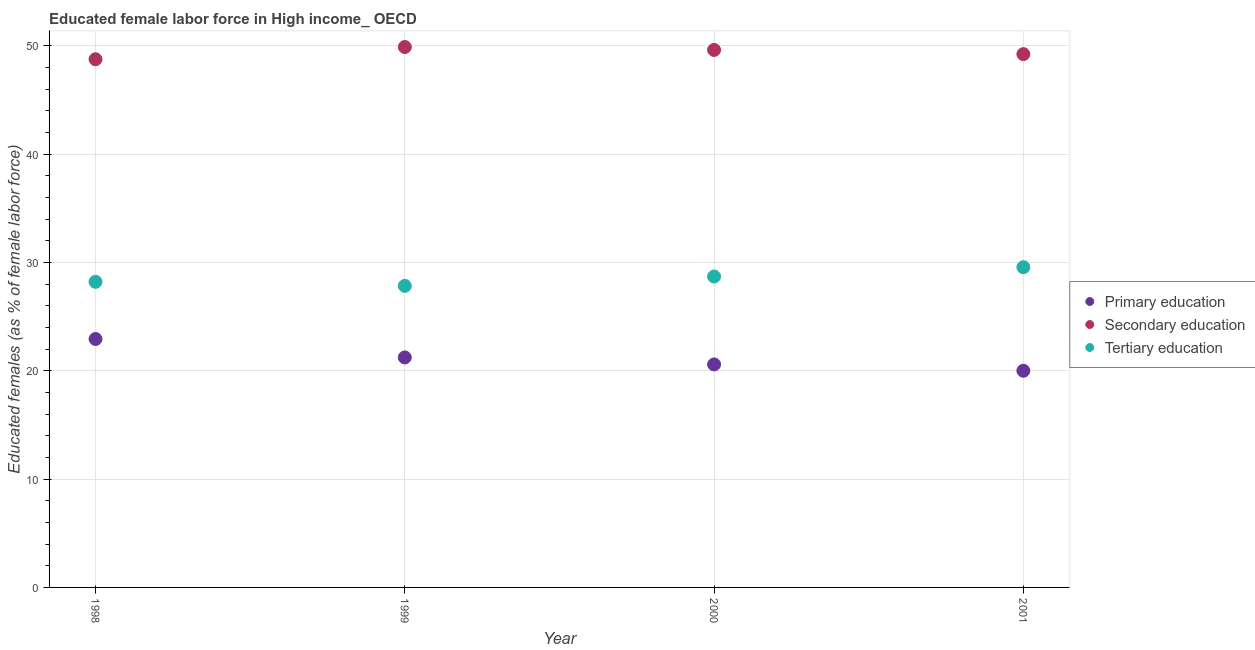How many different coloured dotlines are there?
Ensure brevity in your answer.  3. What is the percentage of female labor force who received secondary education in 1998?
Provide a short and direct response. 48.76. Across all years, what is the maximum percentage of female labor force who received secondary education?
Your answer should be compact. 49.89. Across all years, what is the minimum percentage of female labor force who received tertiary education?
Offer a very short reply. 27.84. What is the total percentage of female labor force who received tertiary education in the graph?
Provide a short and direct response. 114.32. What is the difference between the percentage of female labor force who received primary education in 1998 and that in 2000?
Offer a very short reply. 2.35. What is the difference between the percentage of female labor force who received primary education in 1999 and the percentage of female labor force who received secondary education in 2000?
Provide a short and direct response. -28.39. What is the average percentage of female labor force who received secondary education per year?
Offer a terse response. 49.38. In the year 1998, what is the difference between the percentage of female labor force who received primary education and percentage of female labor force who received secondary education?
Give a very brief answer. -25.83. In how many years, is the percentage of female labor force who received tertiary education greater than 36 %?
Provide a short and direct response. 0. What is the ratio of the percentage of female labor force who received tertiary education in 1999 to that in 2000?
Keep it short and to the point. 0.97. What is the difference between the highest and the second highest percentage of female labor force who received primary education?
Make the answer very short. 1.7. What is the difference between the highest and the lowest percentage of female labor force who received primary education?
Offer a terse response. 2.93. Is the sum of the percentage of female labor force who received tertiary education in 1998 and 1999 greater than the maximum percentage of female labor force who received secondary education across all years?
Make the answer very short. Yes. Is the percentage of female labor force who received primary education strictly greater than the percentage of female labor force who received secondary education over the years?
Ensure brevity in your answer.  No. What is the difference between two consecutive major ticks on the Y-axis?
Keep it short and to the point. 10. Does the graph contain any zero values?
Keep it short and to the point. No. What is the title of the graph?
Provide a succinct answer. Educated female labor force in High income_ OECD. What is the label or title of the X-axis?
Offer a terse response. Year. What is the label or title of the Y-axis?
Offer a very short reply. Educated females (as % of female labor force). What is the Educated females (as % of female labor force) of Primary education in 1998?
Give a very brief answer. 22.94. What is the Educated females (as % of female labor force) of Secondary education in 1998?
Your response must be concise. 48.76. What is the Educated females (as % of female labor force) of Tertiary education in 1998?
Give a very brief answer. 28.22. What is the Educated females (as % of female labor force) in Primary education in 1999?
Make the answer very short. 21.23. What is the Educated females (as % of female labor force) in Secondary education in 1999?
Provide a succinct answer. 49.89. What is the Educated females (as % of female labor force) in Tertiary education in 1999?
Ensure brevity in your answer.  27.84. What is the Educated females (as % of female labor force) in Primary education in 2000?
Provide a succinct answer. 20.59. What is the Educated females (as % of female labor force) in Secondary education in 2000?
Offer a terse response. 49.62. What is the Educated females (as % of female labor force) in Tertiary education in 2000?
Keep it short and to the point. 28.7. What is the Educated females (as % of female labor force) of Primary education in 2001?
Give a very brief answer. 20. What is the Educated females (as % of female labor force) of Secondary education in 2001?
Provide a succinct answer. 49.23. What is the Educated females (as % of female labor force) in Tertiary education in 2001?
Your response must be concise. 29.56. Across all years, what is the maximum Educated females (as % of female labor force) of Primary education?
Make the answer very short. 22.94. Across all years, what is the maximum Educated females (as % of female labor force) of Secondary education?
Offer a very short reply. 49.89. Across all years, what is the maximum Educated females (as % of female labor force) in Tertiary education?
Make the answer very short. 29.56. Across all years, what is the minimum Educated females (as % of female labor force) in Primary education?
Offer a very short reply. 20. Across all years, what is the minimum Educated females (as % of female labor force) in Secondary education?
Provide a short and direct response. 48.76. Across all years, what is the minimum Educated females (as % of female labor force) of Tertiary education?
Make the answer very short. 27.84. What is the total Educated females (as % of female labor force) of Primary education in the graph?
Ensure brevity in your answer.  84.76. What is the total Educated females (as % of female labor force) in Secondary education in the graph?
Provide a short and direct response. 197.51. What is the total Educated females (as % of female labor force) in Tertiary education in the graph?
Offer a very short reply. 114.32. What is the difference between the Educated females (as % of female labor force) in Primary education in 1998 and that in 1999?
Keep it short and to the point. 1.7. What is the difference between the Educated females (as % of female labor force) of Secondary education in 1998 and that in 1999?
Keep it short and to the point. -1.13. What is the difference between the Educated females (as % of female labor force) in Tertiary education in 1998 and that in 1999?
Your response must be concise. 0.38. What is the difference between the Educated females (as % of female labor force) of Primary education in 1998 and that in 2000?
Provide a succinct answer. 2.35. What is the difference between the Educated females (as % of female labor force) of Secondary education in 1998 and that in 2000?
Give a very brief answer. -0.86. What is the difference between the Educated females (as % of female labor force) in Tertiary education in 1998 and that in 2000?
Your answer should be compact. -0.49. What is the difference between the Educated females (as % of female labor force) in Primary education in 1998 and that in 2001?
Your answer should be compact. 2.93. What is the difference between the Educated females (as % of female labor force) of Secondary education in 1998 and that in 2001?
Your answer should be very brief. -0.47. What is the difference between the Educated females (as % of female labor force) in Tertiary education in 1998 and that in 2001?
Offer a terse response. -1.35. What is the difference between the Educated females (as % of female labor force) of Primary education in 1999 and that in 2000?
Your answer should be compact. 0.65. What is the difference between the Educated females (as % of female labor force) of Secondary education in 1999 and that in 2000?
Keep it short and to the point. 0.27. What is the difference between the Educated females (as % of female labor force) of Tertiary education in 1999 and that in 2000?
Your answer should be very brief. -0.86. What is the difference between the Educated females (as % of female labor force) in Primary education in 1999 and that in 2001?
Your answer should be very brief. 1.23. What is the difference between the Educated females (as % of female labor force) of Secondary education in 1999 and that in 2001?
Make the answer very short. 0.66. What is the difference between the Educated females (as % of female labor force) of Tertiary education in 1999 and that in 2001?
Offer a terse response. -1.72. What is the difference between the Educated females (as % of female labor force) in Primary education in 2000 and that in 2001?
Provide a short and direct response. 0.59. What is the difference between the Educated females (as % of female labor force) in Secondary education in 2000 and that in 2001?
Provide a short and direct response. 0.39. What is the difference between the Educated females (as % of female labor force) in Tertiary education in 2000 and that in 2001?
Your response must be concise. -0.86. What is the difference between the Educated females (as % of female labor force) in Primary education in 1998 and the Educated females (as % of female labor force) in Secondary education in 1999?
Keep it short and to the point. -26.96. What is the difference between the Educated females (as % of female labor force) in Primary education in 1998 and the Educated females (as % of female labor force) in Tertiary education in 1999?
Provide a succinct answer. -4.9. What is the difference between the Educated females (as % of female labor force) of Secondary education in 1998 and the Educated females (as % of female labor force) of Tertiary education in 1999?
Keep it short and to the point. 20.92. What is the difference between the Educated females (as % of female labor force) in Primary education in 1998 and the Educated females (as % of female labor force) in Secondary education in 2000?
Offer a terse response. -26.69. What is the difference between the Educated females (as % of female labor force) in Primary education in 1998 and the Educated females (as % of female labor force) in Tertiary education in 2000?
Offer a very short reply. -5.77. What is the difference between the Educated females (as % of female labor force) of Secondary education in 1998 and the Educated females (as % of female labor force) of Tertiary education in 2000?
Your response must be concise. 20.06. What is the difference between the Educated females (as % of female labor force) in Primary education in 1998 and the Educated females (as % of female labor force) in Secondary education in 2001?
Provide a short and direct response. -26.3. What is the difference between the Educated females (as % of female labor force) of Primary education in 1998 and the Educated females (as % of female labor force) of Tertiary education in 2001?
Offer a very short reply. -6.63. What is the difference between the Educated females (as % of female labor force) in Secondary education in 1998 and the Educated females (as % of female labor force) in Tertiary education in 2001?
Offer a very short reply. 19.2. What is the difference between the Educated females (as % of female labor force) of Primary education in 1999 and the Educated females (as % of female labor force) of Secondary education in 2000?
Provide a succinct answer. -28.39. What is the difference between the Educated females (as % of female labor force) of Primary education in 1999 and the Educated females (as % of female labor force) of Tertiary education in 2000?
Give a very brief answer. -7.47. What is the difference between the Educated females (as % of female labor force) in Secondary education in 1999 and the Educated females (as % of female labor force) in Tertiary education in 2000?
Ensure brevity in your answer.  21.19. What is the difference between the Educated females (as % of female labor force) in Primary education in 1999 and the Educated females (as % of female labor force) in Secondary education in 2001?
Give a very brief answer. -28. What is the difference between the Educated females (as % of female labor force) in Primary education in 1999 and the Educated females (as % of female labor force) in Tertiary education in 2001?
Ensure brevity in your answer.  -8.33. What is the difference between the Educated females (as % of female labor force) of Secondary education in 1999 and the Educated females (as % of female labor force) of Tertiary education in 2001?
Give a very brief answer. 20.33. What is the difference between the Educated females (as % of female labor force) in Primary education in 2000 and the Educated females (as % of female labor force) in Secondary education in 2001?
Your answer should be compact. -28.65. What is the difference between the Educated females (as % of female labor force) of Primary education in 2000 and the Educated females (as % of female labor force) of Tertiary education in 2001?
Your response must be concise. -8.97. What is the difference between the Educated females (as % of female labor force) in Secondary education in 2000 and the Educated females (as % of female labor force) in Tertiary education in 2001?
Give a very brief answer. 20.06. What is the average Educated females (as % of female labor force) in Primary education per year?
Provide a short and direct response. 21.19. What is the average Educated females (as % of female labor force) of Secondary education per year?
Make the answer very short. 49.38. What is the average Educated females (as % of female labor force) in Tertiary education per year?
Offer a terse response. 28.58. In the year 1998, what is the difference between the Educated females (as % of female labor force) in Primary education and Educated females (as % of female labor force) in Secondary education?
Your answer should be very brief. -25.83. In the year 1998, what is the difference between the Educated females (as % of female labor force) in Primary education and Educated females (as % of female labor force) in Tertiary education?
Your answer should be very brief. -5.28. In the year 1998, what is the difference between the Educated females (as % of female labor force) in Secondary education and Educated females (as % of female labor force) in Tertiary education?
Provide a succinct answer. 20.55. In the year 1999, what is the difference between the Educated females (as % of female labor force) of Primary education and Educated females (as % of female labor force) of Secondary education?
Provide a succinct answer. -28.66. In the year 1999, what is the difference between the Educated females (as % of female labor force) of Primary education and Educated females (as % of female labor force) of Tertiary education?
Keep it short and to the point. -6.61. In the year 1999, what is the difference between the Educated females (as % of female labor force) of Secondary education and Educated females (as % of female labor force) of Tertiary education?
Your answer should be very brief. 22.05. In the year 2000, what is the difference between the Educated females (as % of female labor force) in Primary education and Educated females (as % of female labor force) in Secondary education?
Your answer should be compact. -29.03. In the year 2000, what is the difference between the Educated females (as % of female labor force) of Primary education and Educated females (as % of female labor force) of Tertiary education?
Offer a very short reply. -8.12. In the year 2000, what is the difference between the Educated females (as % of female labor force) of Secondary education and Educated females (as % of female labor force) of Tertiary education?
Offer a very short reply. 20.92. In the year 2001, what is the difference between the Educated females (as % of female labor force) in Primary education and Educated females (as % of female labor force) in Secondary education?
Provide a succinct answer. -29.23. In the year 2001, what is the difference between the Educated females (as % of female labor force) of Primary education and Educated females (as % of female labor force) of Tertiary education?
Make the answer very short. -9.56. In the year 2001, what is the difference between the Educated females (as % of female labor force) in Secondary education and Educated females (as % of female labor force) in Tertiary education?
Make the answer very short. 19.67. What is the ratio of the Educated females (as % of female labor force) in Primary education in 1998 to that in 1999?
Offer a terse response. 1.08. What is the ratio of the Educated females (as % of female labor force) of Secondary education in 1998 to that in 1999?
Give a very brief answer. 0.98. What is the ratio of the Educated females (as % of female labor force) in Tertiary education in 1998 to that in 1999?
Give a very brief answer. 1.01. What is the ratio of the Educated females (as % of female labor force) in Primary education in 1998 to that in 2000?
Give a very brief answer. 1.11. What is the ratio of the Educated females (as % of female labor force) in Secondary education in 1998 to that in 2000?
Offer a terse response. 0.98. What is the ratio of the Educated females (as % of female labor force) in Tertiary education in 1998 to that in 2000?
Offer a terse response. 0.98. What is the ratio of the Educated females (as % of female labor force) in Primary education in 1998 to that in 2001?
Offer a very short reply. 1.15. What is the ratio of the Educated females (as % of female labor force) in Secondary education in 1998 to that in 2001?
Provide a succinct answer. 0.99. What is the ratio of the Educated females (as % of female labor force) of Tertiary education in 1998 to that in 2001?
Make the answer very short. 0.95. What is the ratio of the Educated females (as % of female labor force) of Primary education in 1999 to that in 2000?
Provide a short and direct response. 1.03. What is the ratio of the Educated females (as % of female labor force) of Secondary education in 1999 to that in 2000?
Ensure brevity in your answer.  1.01. What is the ratio of the Educated females (as % of female labor force) of Tertiary education in 1999 to that in 2000?
Ensure brevity in your answer.  0.97. What is the ratio of the Educated females (as % of female labor force) of Primary education in 1999 to that in 2001?
Your answer should be compact. 1.06. What is the ratio of the Educated females (as % of female labor force) in Secondary education in 1999 to that in 2001?
Ensure brevity in your answer.  1.01. What is the ratio of the Educated females (as % of female labor force) of Tertiary education in 1999 to that in 2001?
Offer a terse response. 0.94. What is the ratio of the Educated females (as % of female labor force) in Primary education in 2000 to that in 2001?
Offer a terse response. 1.03. What is the ratio of the Educated females (as % of female labor force) in Secondary education in 2000 to that in 2001?
Your answer should be very brief. 1.01. What is the difference between the highest and the second highest Educated females (as % of female labor force) of Primary education?
Your answer should be compact. 1.7. What is the difference between the highest and the second highest Educated females (as % of female labor force) of Secondary education?
Ensure brevity in your answer.  0.27. What is the difference between the highest and the second highest Educated females (as % of female labor force) of Tertiary education?
Make the answer very short. 0.86. What is the difference between the highest and the lowest Educated females (as % of female labor force) in Primary education?
Ensure brevity in your answer.  2.93. What is the difference between the highest and the lowest Educated females (as % of female labor force) in Secondary education?
Ensure brevity in your answer.  1.13. What is the difference between the highest and the lowest Educated females (as % of female labor force) of Tertiary education?
Your answer should be very brief. 1.72. 